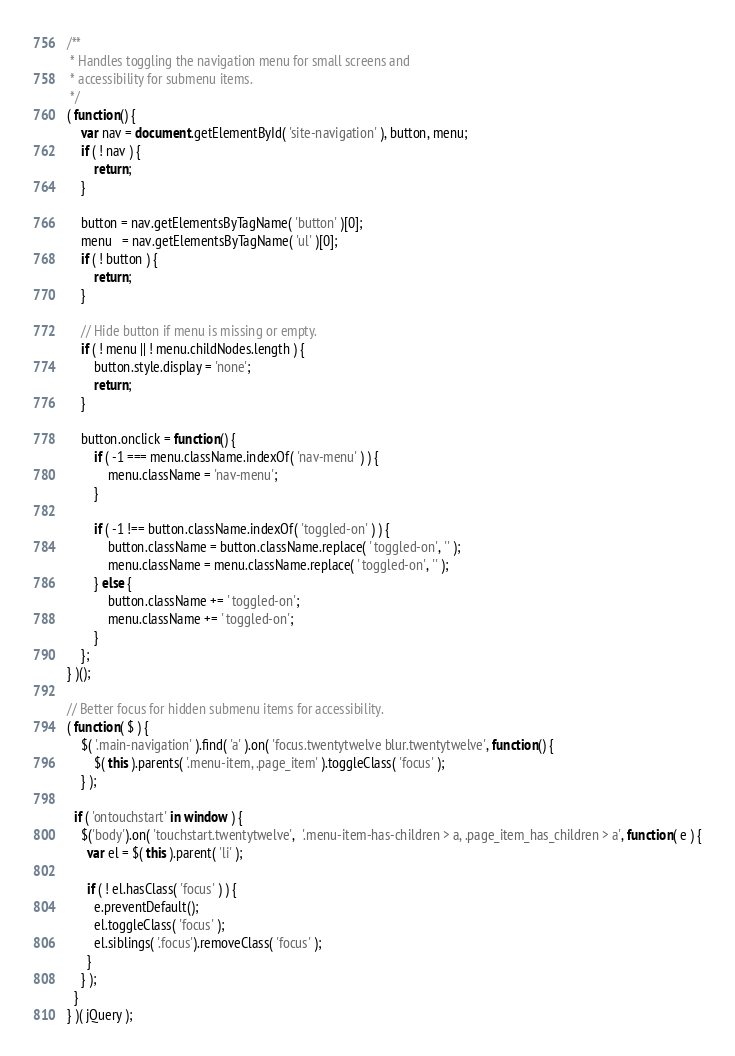Convert code to text. <code><loc_0><loc_0><loc_500><loc_500><_JavaScript_>/**
 * Handles toggling the navigation menu for small screens and
 * accessibility for submenu items.
 */
( function() {
	var nav = document.getElementById( 'site-navigation' ), button, menu;
	if ( ! nav ) {
		return;
	}

	button = nav.getElementsByTagName( 'button' )[0];
	menu   = nav.getElementsByTagName( 'ul' )[0];
	if ( ! button ) {
		return;
	}

	// Hide button if menu is missing or empty.
	if ( ! menu || ! menu.childNodes.length ) {
		button.style.display = 'none';
		return;
	}

	button.onclick = function() {
		if ( -1 === menu.className.indexOf( 'nav-menu' ) ) {
			menu.className = 'nav-menu';
		}

		if ( -1 !== button.className.indexOf( 'toggled-on' ) ) {
			button.className = button.className.replace( ' toggled-on', '' );
			menu.className = menu.className.replace( ' toggled-on', '' );
		} else {
			button.className += ' toggled-on';
			menu.className += ' toggled-on';
		}
	};
} )();

// Better focus for hidden submenu items for accessibility.
( function( $ ) {
	$( '.main-navigation' ).find( 'a' ).on( 'focus.twentytwelve blur.twentytwelve', function() {
		$( this ).parents( '.menu-item, .page_item' ).toggleClass( 'focus' );
	} );

  if ( 'ontouchstart' in window ) {
    $('body').on( 'touchstart.twentytwelve',  '.menu-item-has-children > a, .page_item_has_children > a', function( e ) {
      var el = $( this ).parent( 'li' );

      if ( ! el.hasClass( 'focus' ) ) {
        e.preventDefault();
        el.toggleClass( 'focus' );
        el.siblings( '.focus').removeClass( 'focus' );
      }
    } );
  }
} )( jQuery );
</code> 